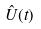Convert formula to latex. <formula><loc_0><loc_0><loc_500><loc_500>\hat { U } ( t )</formula> 